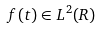<formula> <loc_0><loc_0><loc_500><loc_500>f ( t ) \in L ^ { 2 } ( R )</formula> 